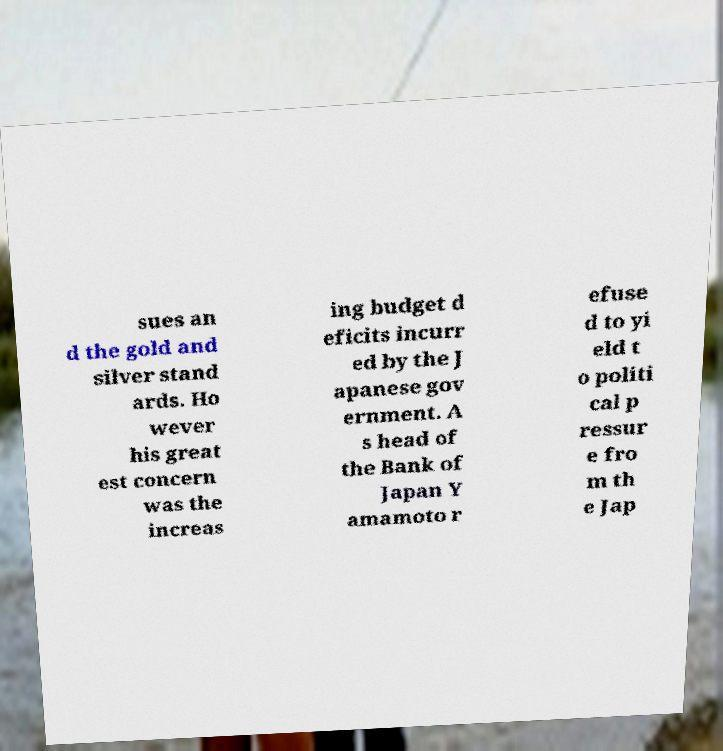Could you extract and type out the text from this image? sues an d the gold and silver stand ards. Ho wever his great est concern was the increas ing budget d eficits incurr ed by the J apanese gov ernment. A s head of the Bank of Japan Y amamoto r efuse d to yi eld t o politi cal p ressur e fro m th e Jap 